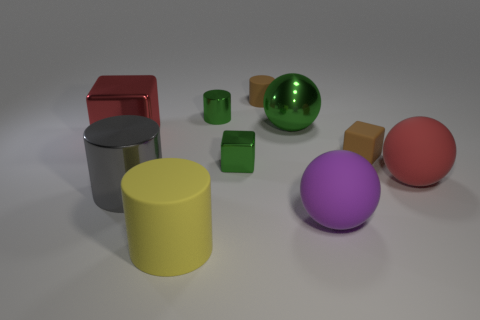There is a small brown object in front of the green object behind the large green shiny sphere; what is its shape?
Your answer should be compact. Cube. There is a green thing that is the same shape as the large yellow object; what is it made of?
Your answer should be very brief. Metal. There is a metal sphere that is the same size as the red metallic block; what is its color?
Give a very brief answer. Green. Is the number of gray shiny things that are to the right of the gray cylinder the same as the number of large red metallic blocks?
Give a very brief answer. No. What is the color of the big shiny object that is in front of the small shiny thing that is in front of the big green shiny sphere?
Your answer should be very brief. Gray. What size is the rubber cylinder that is behind the rubber sphere that is behind the purple sphere?
Make the answer very short. Small. What is the size of the matte ball that is the same color as the big cube?
Your response must be concise. Large. What number of other objects are the same size as the red matte object?
Give a very brief answer. 5. There is a shiny block to the left of the metallic cube in front of the tiny matte object in front of the green cylinder; what is its color?
Ensure brevity in your answer.  Red. How many other things are the same shape as the gray object?
Make the answer very short. 3. 